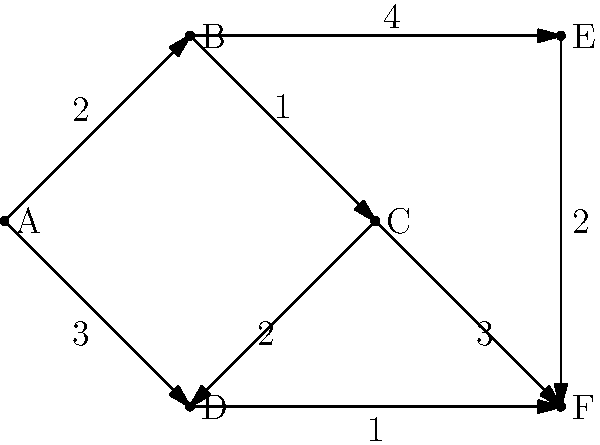Given the network topology represented by the graph above, where nodes represent routers and edges represent connections with their associated weights (representing transmission delays in milliseconds), what is the shortest path from node A to node F, and what is its total delay? To find the shortest path from node A to node F, we can use Dijkstra's algorithm:

1. Initialize:
   - Distance to A: 0
   - Distance to all other nodes: infinity
   - Previous node for all nodes: undefined

2. Visit node A:
   - Update B: distance 2, previous A
   - Update D: distance 3, previous A

3. Visit node B (closest unvisited):
   - Update C: distance 3 (2+1), previous B
   - Update E: distance 6 (2+4), previous B

4. Visit node D (next closest):
   - Update F: distance 4 (3+1), previous D

5. Visit node C:
   - Update F: distance 6 (3+3), not shorter than current

6. Node F has been reached, so we stop.

The shortest path is A -> D -> F with a total delay of 4 ms.
Answer: A -> D -> F, 4 ms 